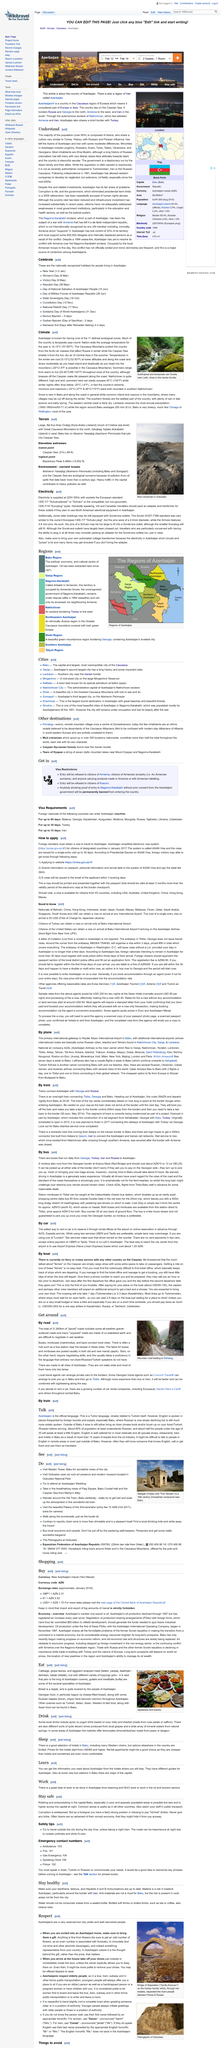Outline some significant characteristics in this image. The starting price for hotels in Baku is approximately USD60 and higher. Khinalug, the scenic and remote mountain village, is known for its breathtaking beauty and stunning natural landscapes. The subject of the photo is the mud volcanoes in Gobustan, which can be identified as the predominant feature in the image. The e-visa is accessible to citizens of 93 countries, making it a convenient option for travelers. According to a recent survey, approximately 80% of the population in Baku are able to understand Russian at least, showing that Russian is a widely spoken and understood language in the city. 